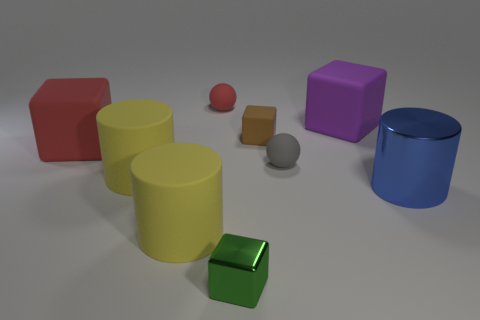Subtract all green cubes. How many cubes are left? 3 Subtract all blue cubes. Subtract all green balls. How many cubes are left? 4 Add 1 tiny brown objects. How many objects exist? 10 Subtract all spheres. How many objects are left? 7 Add 8 yellow shiny balls. How many yellow shiny balls exist? 8 Subtract 1 green blocks. How many objects are left? 8 Subtract all large purple rubber things. Subtract all tiny red cylinders. How many objects are left? 8 Add 4 green blocks. How many green blocks are left? 5 